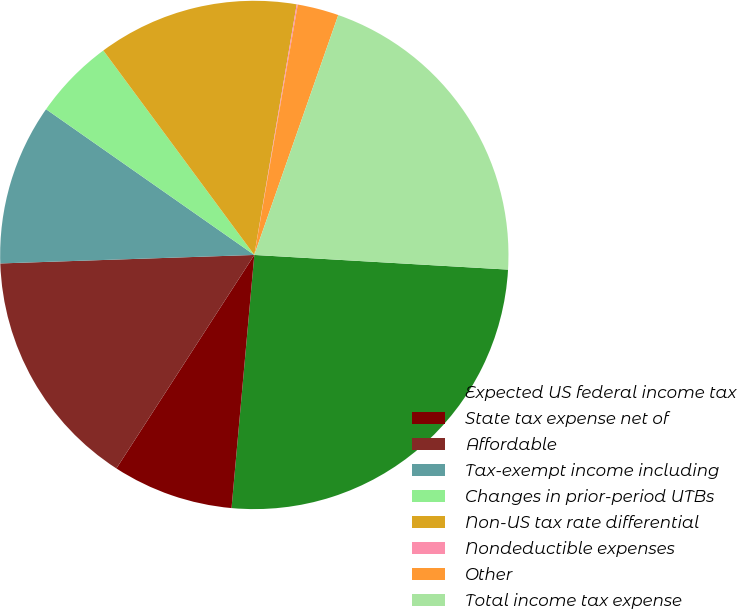Convert chart. <chart><loc_0><loc_0><loc_500><loc_500><pie_chart><fcel>Expected US federal income tax<fcel>State tax expense net of<fcel>Affordable<fcel>Tax-exempt income including<fcel>Changes in prior-period UTBs<fcel>Non-US tax rate differential<fcel>Nondeductible expenses<fcel>Other<fcel>Total income tax expense<nl><fcel>25.51%<fcel>7.7%<fcel>15.34%<fcel>10.25%<fcel>5.16%<fcel>12.79%<fcel>0.07%<fcel>2.62%<fcel>20.56%<nl></chart> 